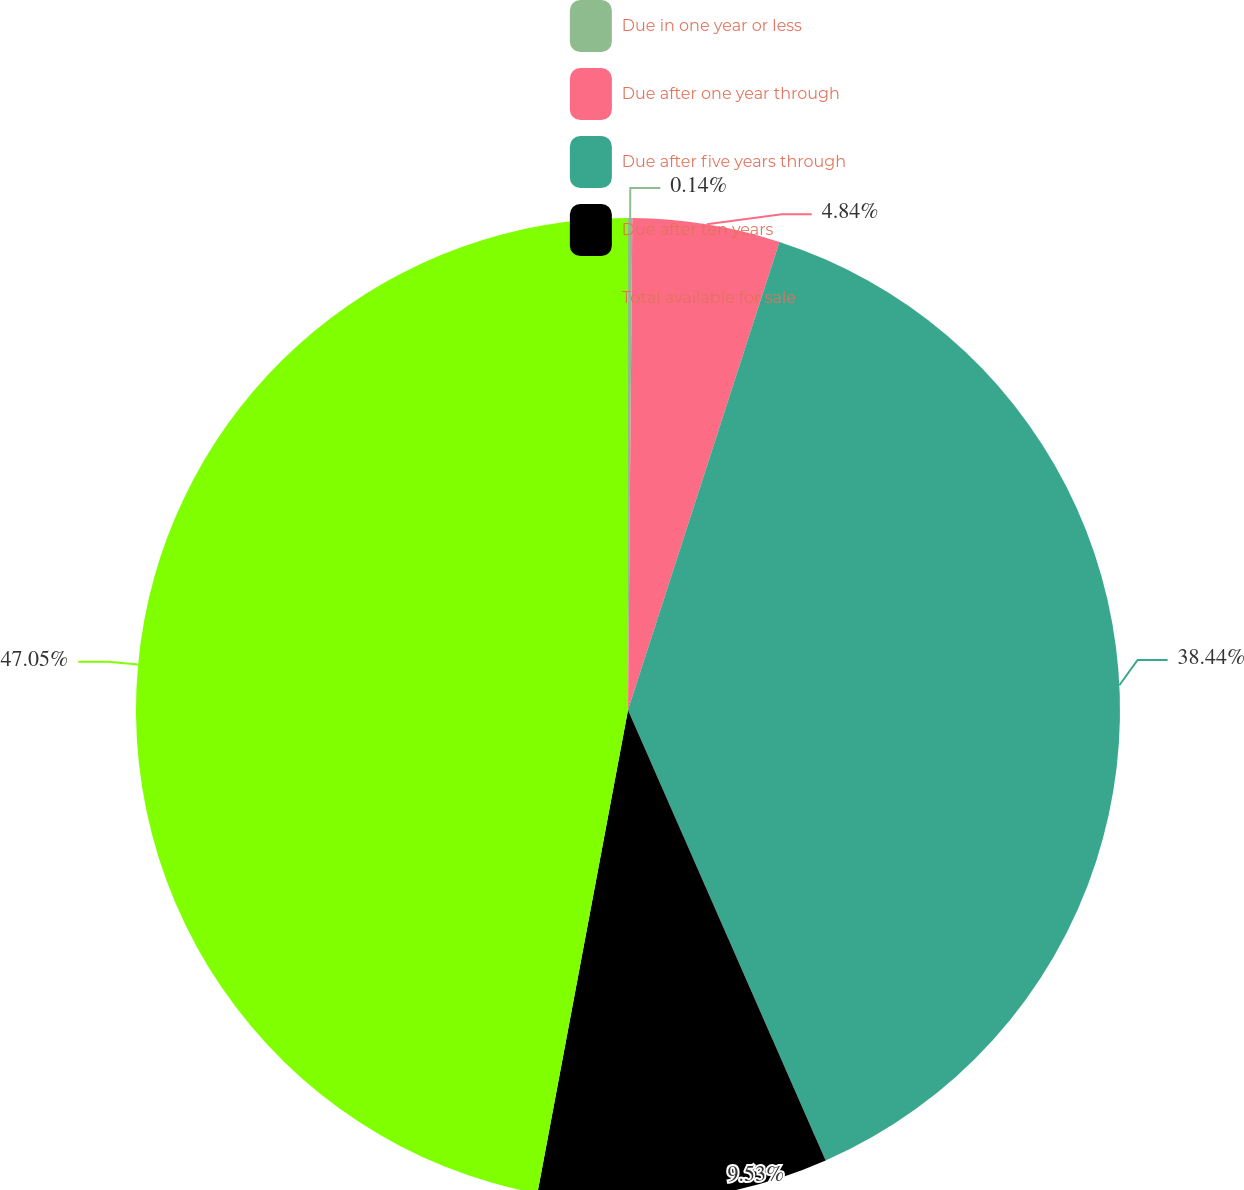Convert chart. <chart><loc_0><loc_0><loc_500><loc_500><pie_chart><fcel>Due in one year or less<fcel>Due after one year through<fcel>Due after five years through<fcel>Due after ten years<fcel>Total available for sale<nl><fcel>0.14%<fcel>4.84%<fcel>38.44%<fcel>9.53%<fcel>47.05%<nl></chart> 